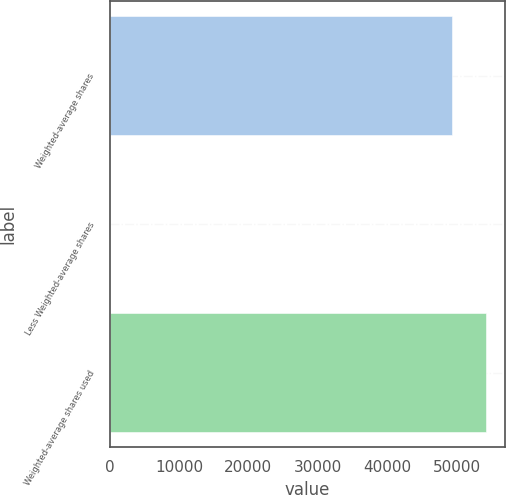Convert chart to OTSL. <chart><loc_0><loc_0><loc_500><loc_500><bar_chart><fcel>Weighted-average shares<fcel>Less Weighted-average shares<fcel>Weighted-average shares used<nl><fcel>49372.8<fcel>36<fcel>54244.6<nl></chart> 